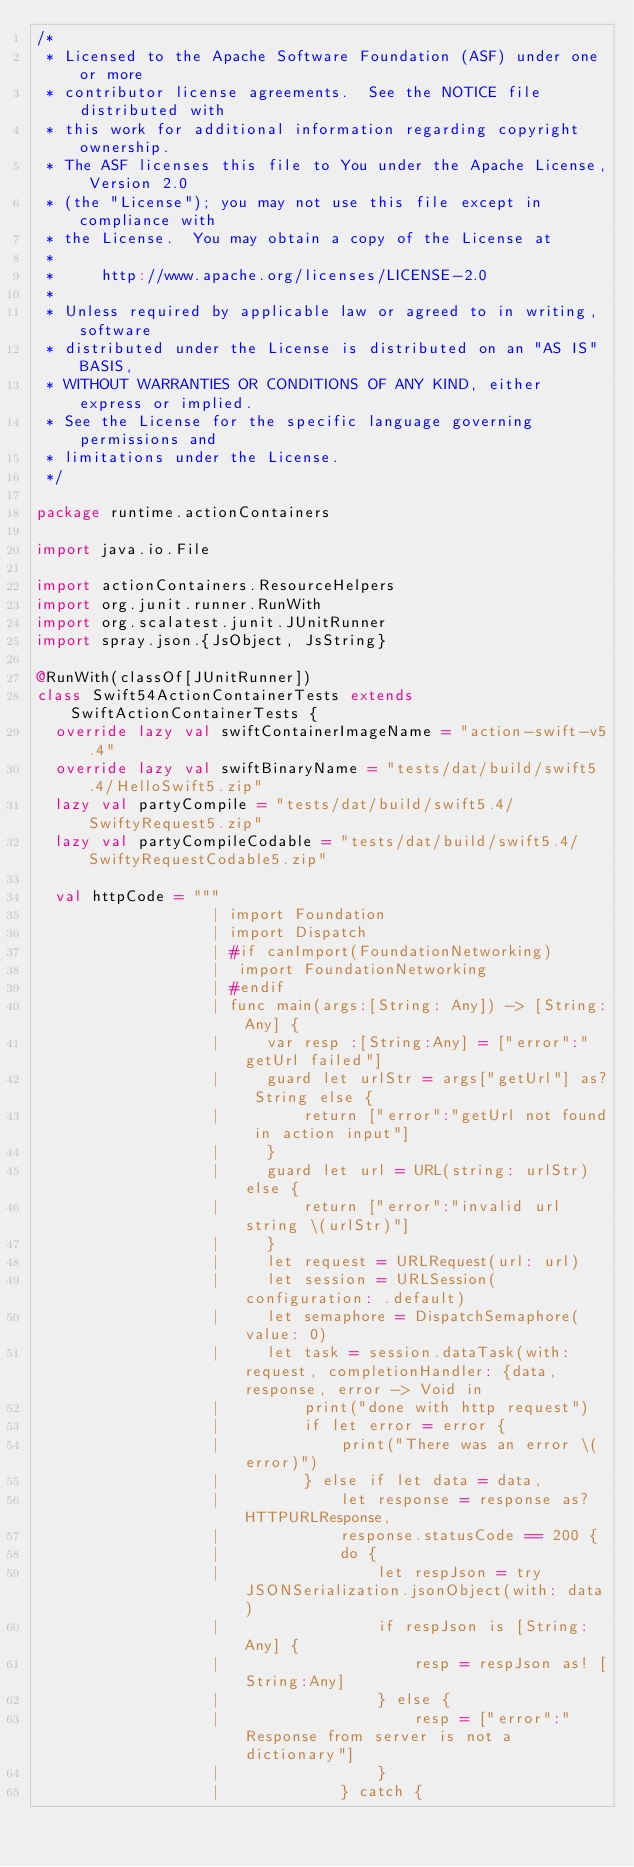Convert code to text. <code><loc_0><loc_0><loc_500><loc_500><_Scala_>/*
 * Licensed to the Apache Software Foundation (ASF) under one or more
 * contributor license agreements.  See the NOTICE file distributed with
 * this work for additional information regarding copyright ownership.
 * The ASF licenses this file to You under the Apache License, Version 2.0
 * (the "License"); you may not use this file except in compliance with
 * the License.  You may obtain a copy of the License at
 *
 *     http://www.apache.org/licenses/LICENSE-2.0
 *
 * Unless required by applicable law or agreed to in writing, software
 * distributed under the License is distributed on an "AS IS" BASIS,
 * WITHOUT WARRANTIES OR CONDITIONS OF ANY KIND, either express or implied.
 * See the License for the specific language governing permissions and
 * limitations under the License.
 */

package runtime.actionContainers

import java.io.File

import actionContainers.ResourceHelpers
import org.junit.runner.RunWith
import org.scalatest.junit.JUnitRunner
import spray.json.{JsObject, JsString}

@RunWith(classOf[JUnitRunner])
class Swift54ActionContainerTests extends SwiftActionContainerTests {
  override lazy val swiftContainerImageName = "action-swift-v5.4"
  override lazy val swiftBinaryName = "tests/dat/build/swift5.4/HelloSwift5.zip"
  lazy val partyCompile = "tests/dat/build/swift5.4/SwiftyRequest5.zip"
  lazy val partyCompileCodable = "tests/dat/build/swift5.4/SwiftyRequestCodable5.zip"

  val httpCode = """
                   | import Foundation
                   | import Dispatch
                   | #if canImport(FoundationNetworking)
                   |  import FoundationNetworking
                   | #endif
                   | func main(args:[String: Any]) -> [String:Any] {
                   |     var resp :[String:Any] = ["error":"getUrl failed"]
                   |     guard let urlStr = args["getUrl"] as? String else {
                   |         return ["error":"getUrl not found in action input"]
                   |     }
                   |     guard let url = URL(string: urlStr) else {
                   |         return ["error":"invalid url string \(urlStr)"]
                   |     }
                   |     let request = URLRequest(url: url)
                   |     let session = URLSession(configuration: .default)
                   |     let semaphore = DispatchSemaphore(value: 0)
                   |     let task = session.dataTask(with: request, completionHandler: {data, response, error -> Void in
                   |         print("done with http request")
                   |         if let error = error {
                   |             print("There was an error \(error)")
                   |         } else if let data = data,
                   |             let response = response as? HTTPURLResponse,
                   |             response.statusCode == 200 {
                   |             do {
                   |                 let respJson = try JSONSerialization.jsonObject(with: data)
                   |                 if respJson is [String:Any] {
                   |                     resp = respJson as! [String:Any]
                   |                 } else {
                   |                     resp = ["error":"Response from server is not a dictionary"]
                   |                 }
                   |             } catch {</code> 